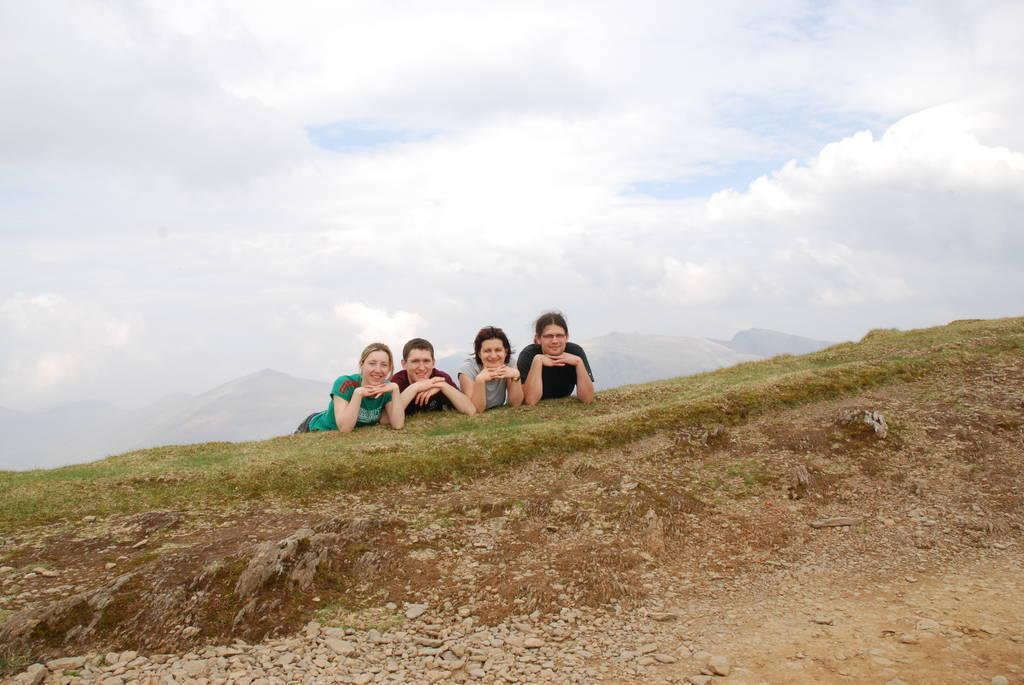How many people are in the image? There are four persons in the image. What color shirt is the person on the left wearing? The person on the left is wearing a green shirt. What color shirt is the person on the right wearing? The person on the right is wearing a black shirt. What can be seen in the background of the image? The background of the image includes the sky. What colors are visible in the sky? The sky is in white and blue color. What type of yarn is the person on the left using to start knitting in the image? There is no yarn or knitting activity present in the image. What is the name of the son of the person on the right in the image? There is no information about the person's son in the image. 